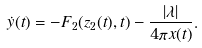<formula> <loc_0><loc_0><loc_500><loc_500>\dot { y } ( t ) = - F _ { 2 } ( z _ { 2 } ( t ) , t ) - \frac { | \lambda | } { 4 \pi x ( t ) } .</formula> 